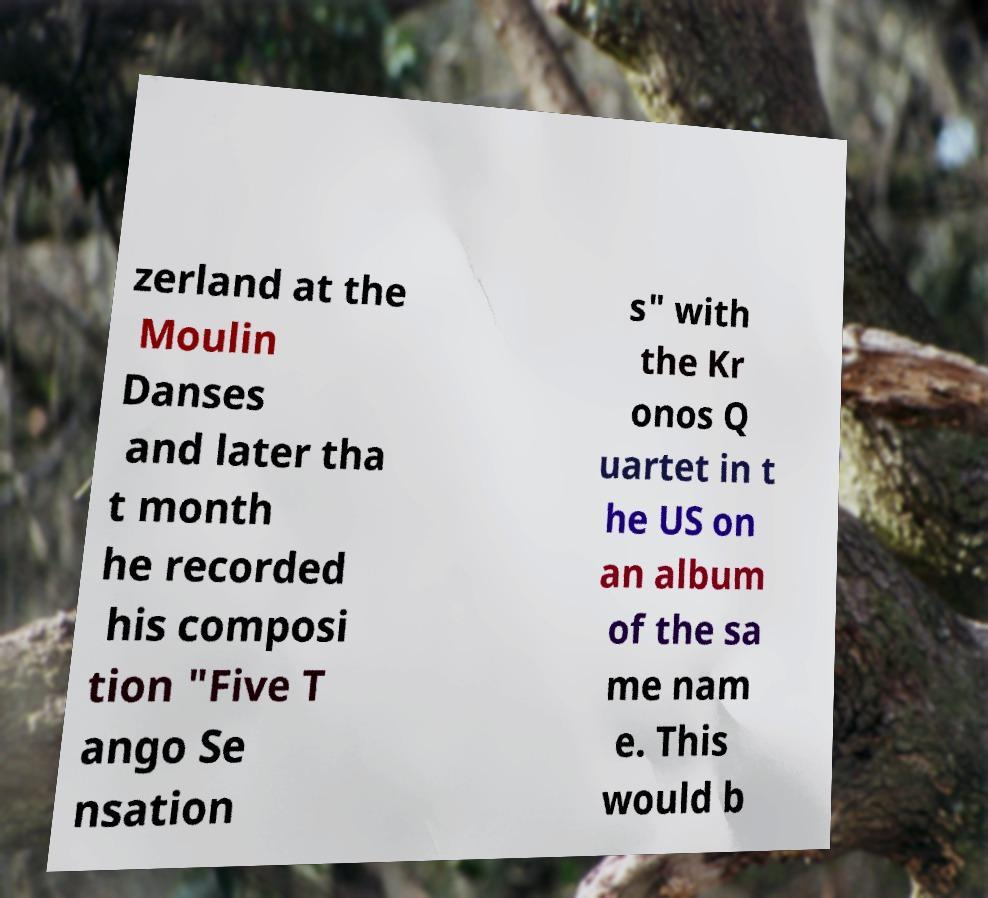For documentation purposes, I need the text within this image transcribed. Could you provide that? zerland at the Moulin Danses and later tha t month he recorded his composi tion "Five T ango Se nsation s" with the Kr onos Q uartet in t he US on an album of the sa me nam e. This would b 